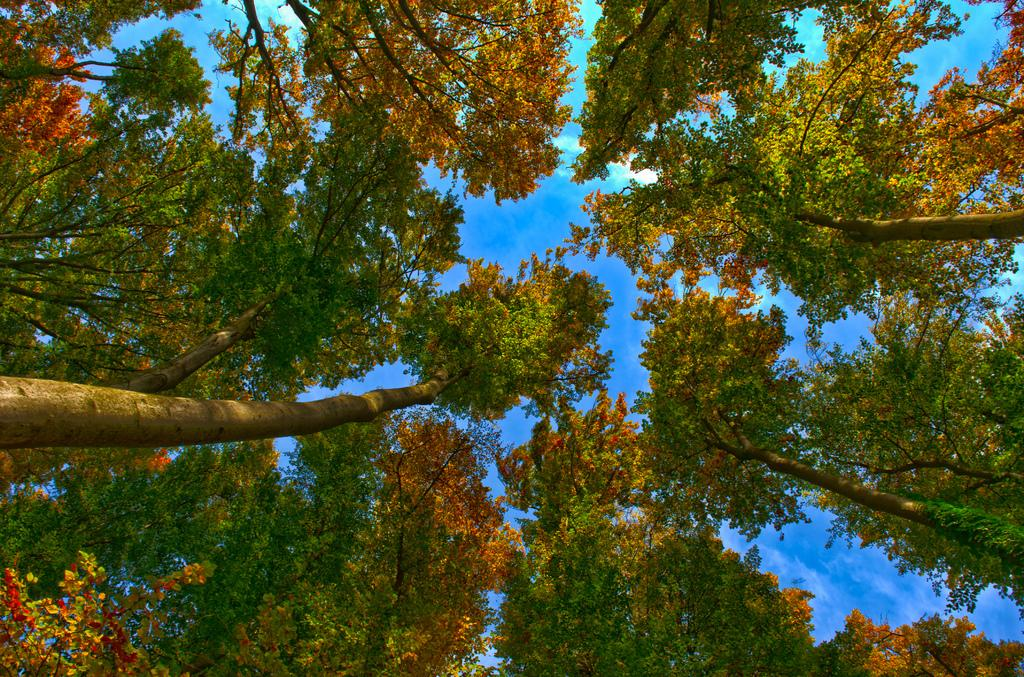What type of vegetation can be seen in the image? There are trees in the image. What part of the natural environment is visible in the image? The sky is visible in the background of the image. What degree does the pencil have in the image? There is no pencil present in the image, so it cannot have a degree. 